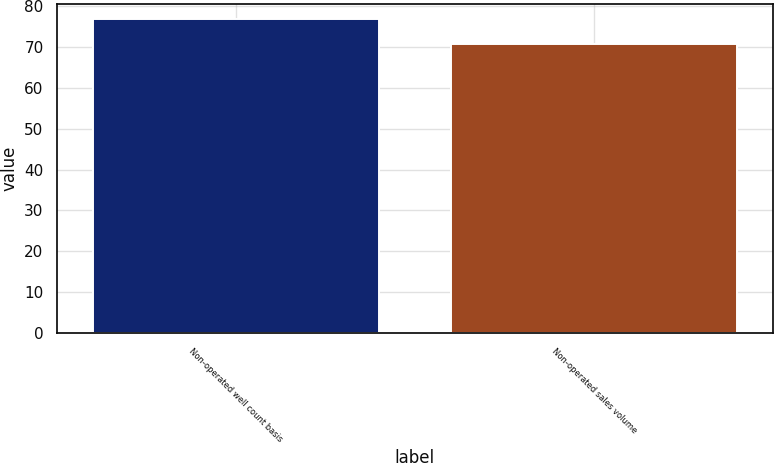<chart> <loc_0><loc_0><loc_500><loc_500><bar_chart><fcel>Non-operated well count basis<fcel>Non-operated sales volume<nl><fcel>76.7<fcel>70.7<nl></chart> 